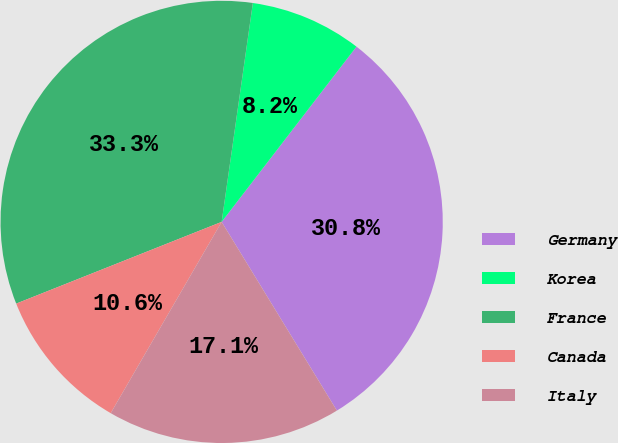Convert chart to OTSL. <chart><loc_0><loc_0><loc_500><loc_500><pie_chart><fcel>Germany<fcel>Korea<fcel>France<fcel>Canada<fcel>Italy<nl><fcel>30.84%<fcel>8.18%<fcel>33.28%<fcel>10.61%<fcel>17.09%<nl></chart> 